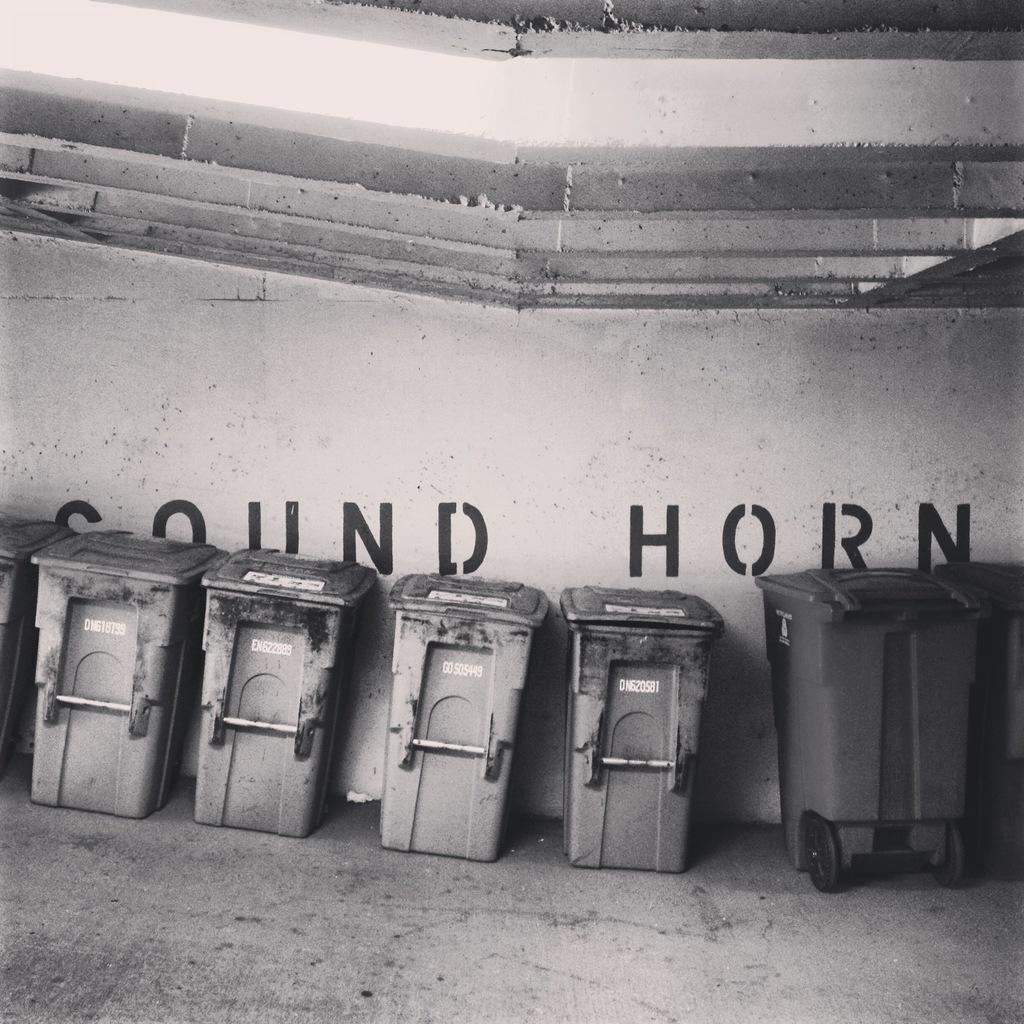<image>
Present a compact description of the photo's key features. Trash cans are lined up against a wall that says SOUND HORN 